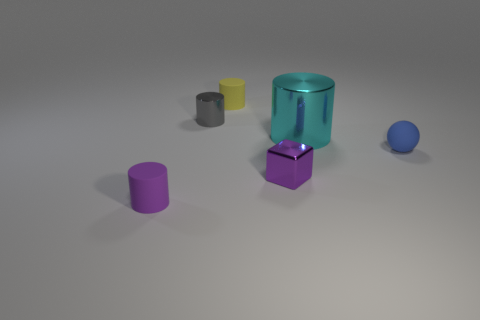Are there any other things that have the same shape as the tiny blue object?
Give a very brief answer. No. Do the big cyan thing and the tiny metallic thing that is behind the big cylinder have the same shape?
Keep it short and to the point. Yes. How many rubber objects are either blue objects or red cubes?
Offer a very short reply. 1. Are there any small cylinders that have the same color as the shiny block?
Offer a terse response. Yes. Are there any tiny gray metallic objects?
Your answer should be very brief. Yes. Is the big cyan object the same shape as the tiny yellow rubber object?
Offer a terse response. Yes. How many tiny things are either yellow rubber things or brown shiny objects?
Ensure brevity in your answer.  1. What color is the metal block?
Make the answer very short. Purple. The matte thing that is behind the tiny metal object that is left of the small metallic block is what shape?
Ensure brevity in your answer.  Cylinder. Are there any big cyan cylinders made of the same material as the tiny gray cylinder?
Keep it short and to the point. Yes. 